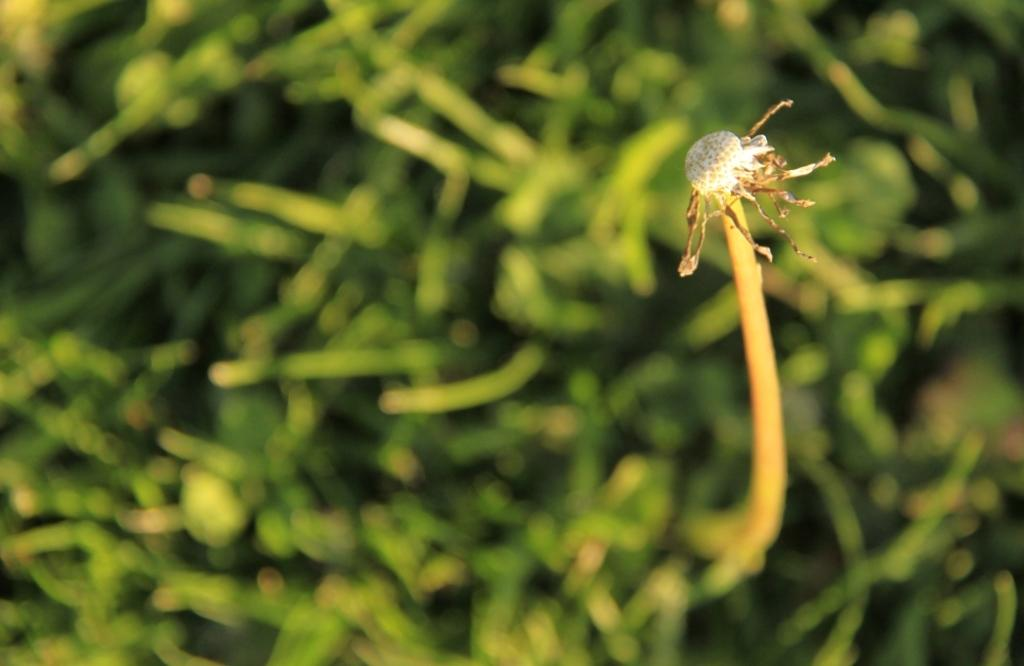What type of creature is in the image? There is a white-colored insect in the image. Where is the insect located? The insect is sitting on the grass. What can be seen in the background of the image? There is grass visible in the background of the image. What year is depicted in the image? The image does not depict a specific year; it is a photograph of an insect and grass. 